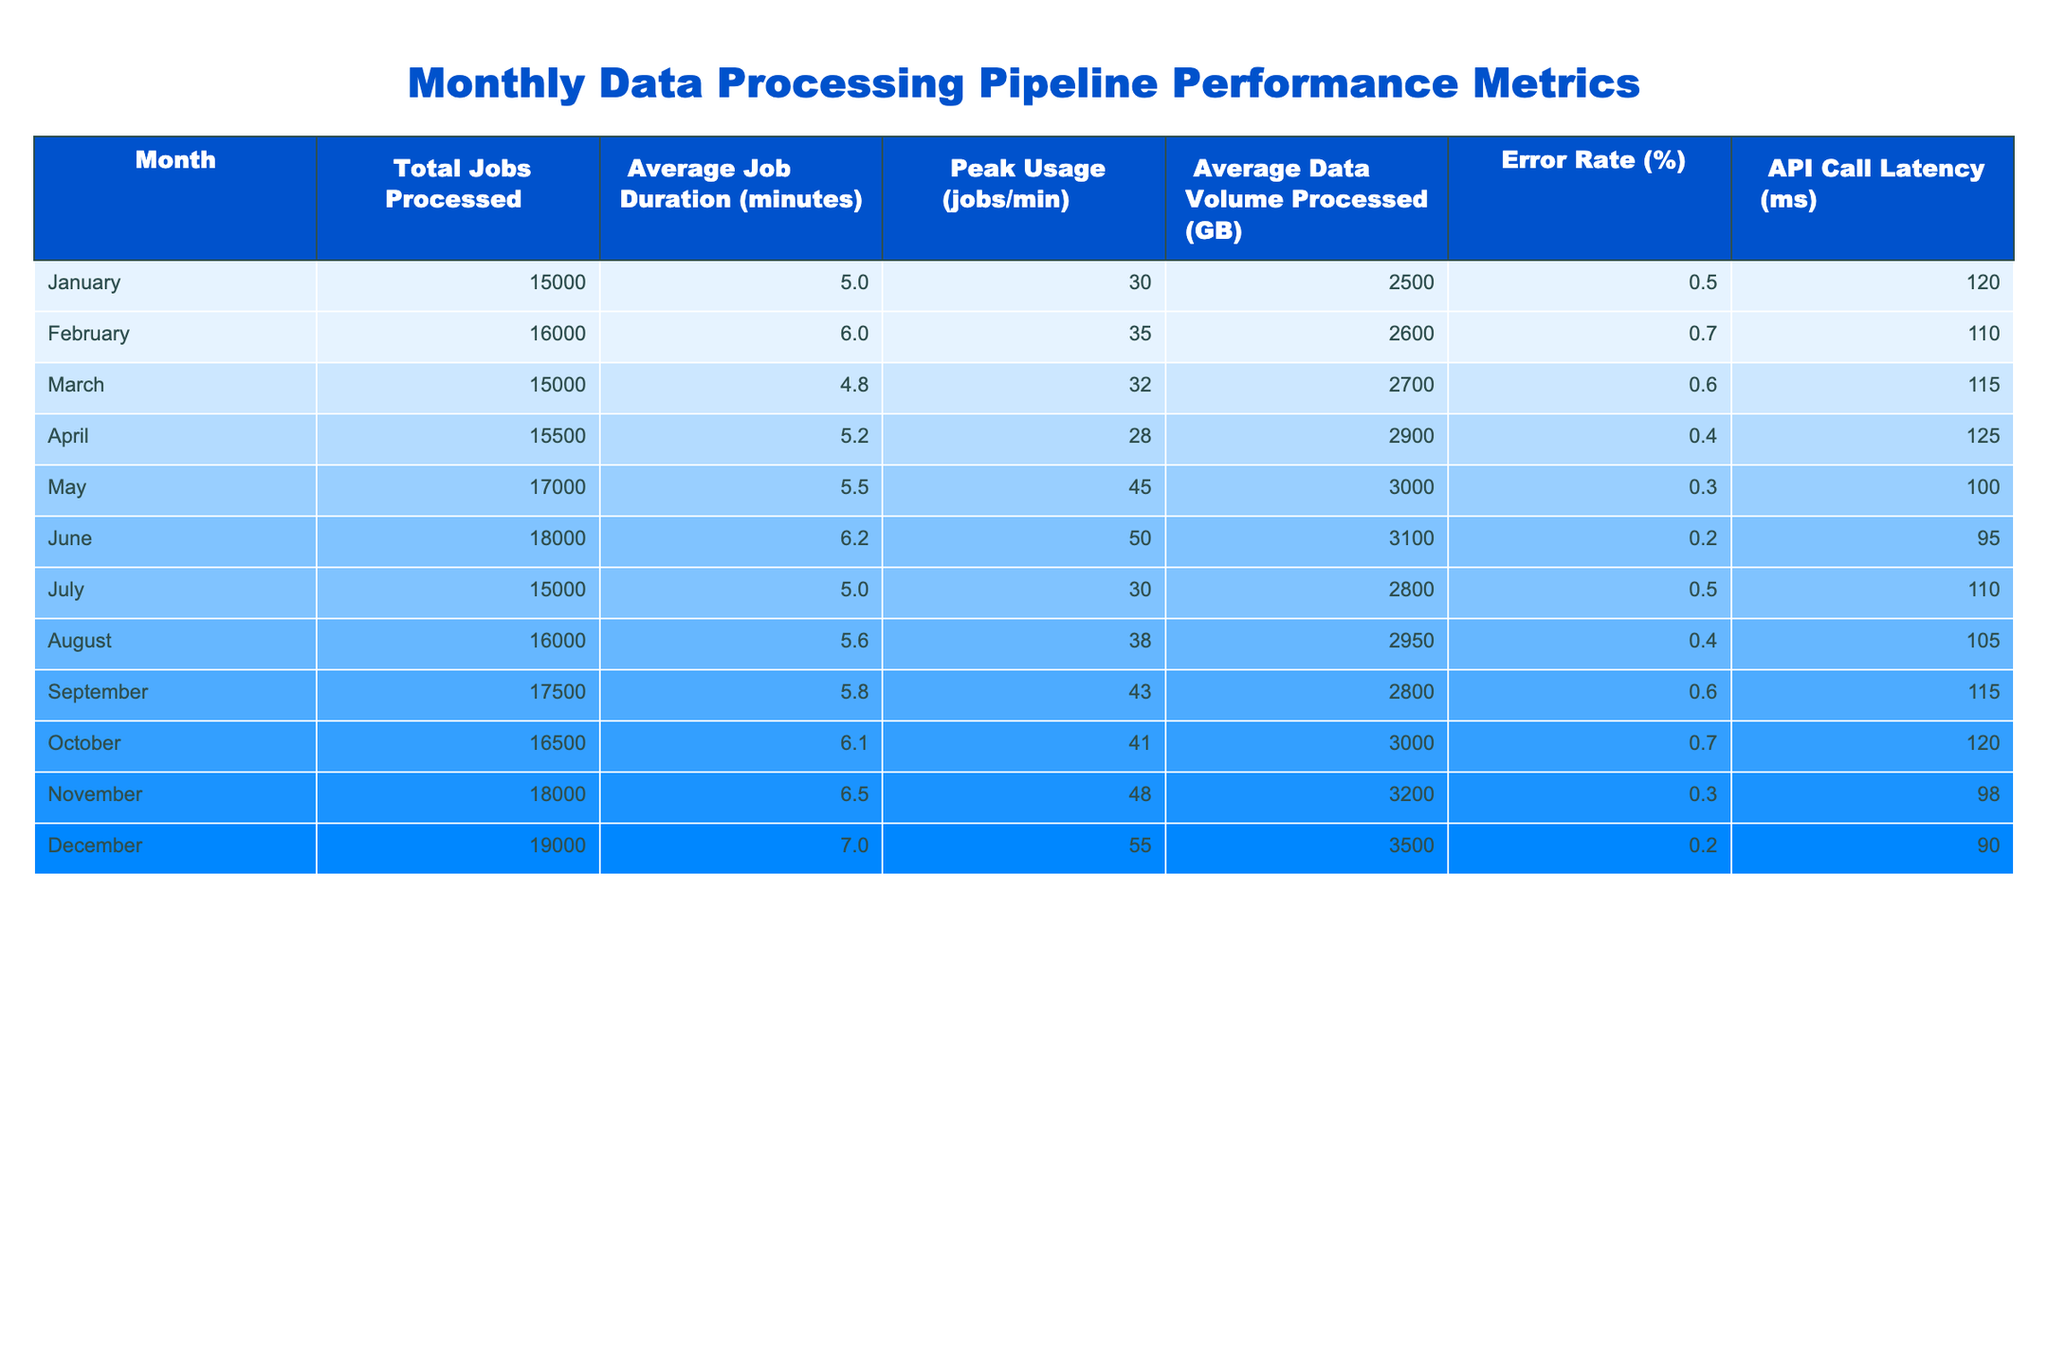What is the total number of jobs processed in December? The total number of jobs processed is found in the "Total Jobs Processed" column for December, which states 19000.
Answer: 19000 What was the average job duration in July? The average job duration for July is located in the "Average Job Duration (minutes)" column, which shows a value of 5.0 minutes.
Answer: 5.0 In which month was the peak usage highest, and what was that value? The peak usage can be found in the "Peak Usage (jobs/min)" column. The highest value is 55 jobs/min in December, making it the month with the peak usage.
Answer: December, 55 What is the average error rate across all months? To calculate the average error rate, sum all the error rates: 0.5 + 0.7 + 0.6 + 0.4 + 0.3 + 0.2 + 0.5 + 0.4 + 0.6 + 0.7 + 0.3 + 0.2 =  5.6. There are 12 months, so divide by 12: 5.6 / 12 = 0.4667.
Answer: 0.47 Did the average data volume processed exceed 3000 GB in any month? Looking at the "Average Data Volume Processed (GB)" column, the values exceed 3000 GB only in December (3500 GB), so the answer is true.
Answer: Yes What was the difference in average job duration between May and March? The average job duration for May is 5.5 minutes and for March is 4.8 minutes. The difference is 5.5 - 4.8 = 0.7 minutes.
Answer: 0.7 Which month experienced the lowest API call latency, and what was the latency? Examining the "API Call Latency (ms)" column, the lowest latency is 90 ms recorded in December, making it the month with the lowest latency.
Answer: December, 90 What is the total number of jobs processed in the first half of the year compared to the second half? Total for the first half (January to June) is 15000 + 16000 + 15000 + 15500 + 17000 + 18000 = 96500. Total for the second half (July to December) is 15000 + 16000 + 17500 + 16500 + 18000 + 19000 = 102000. The second half (102000) has more jobs than the first half (96500).
Answer: Second half Which month had the highest error rate, and what was the rate? The highest error rate can be observed in October with a value of 0.7%. This makes October the month with the highest error rate.
Answer: October, 0.7 